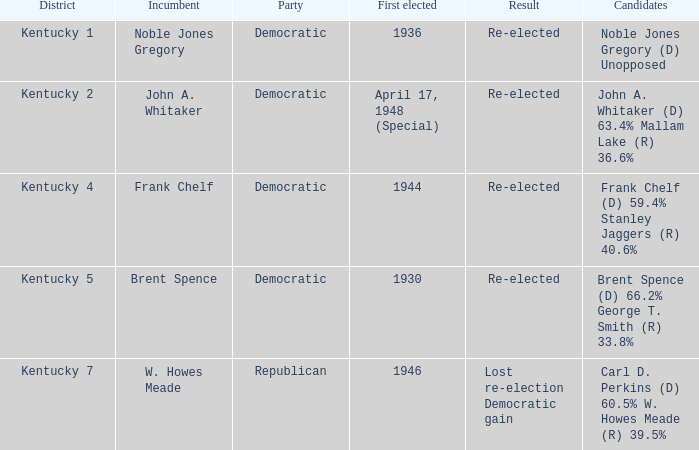What was the consequence of the election incumbent brent spence was involved in? Re-elected. 